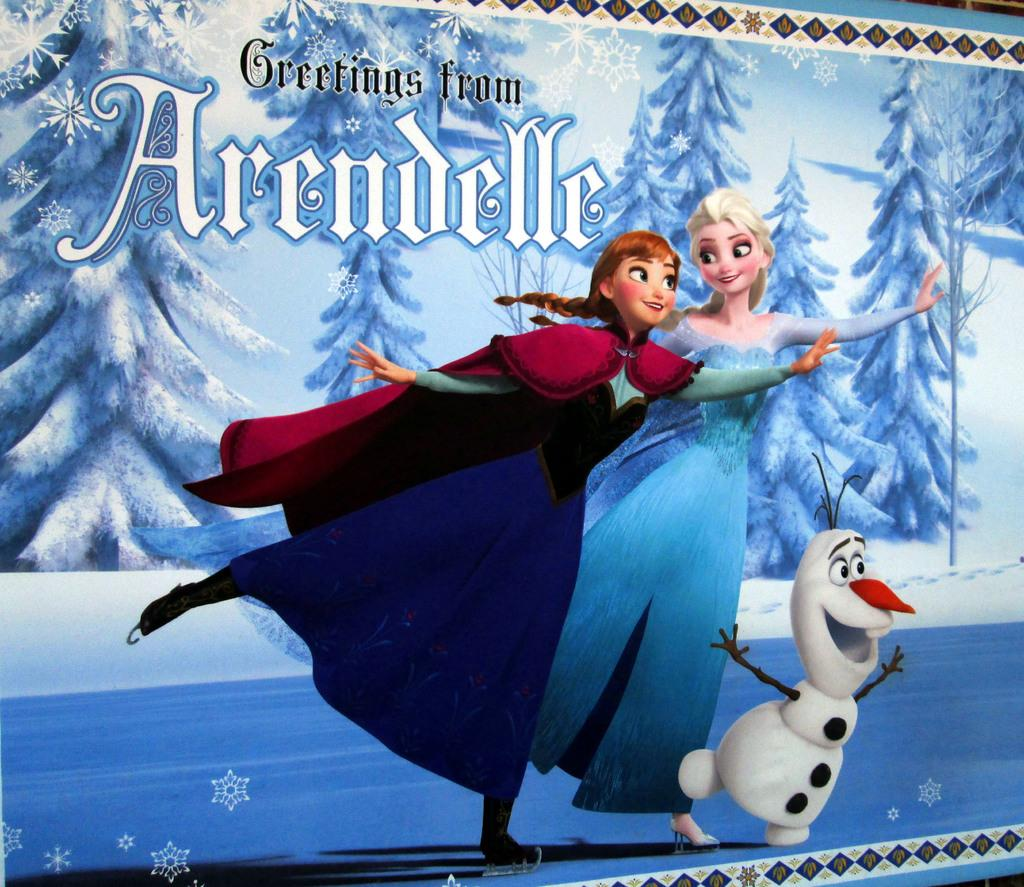<image>
Offer a succinct explanation of the picture presented. A post card featuring Frozen characters that says Greetings from Arendelle 